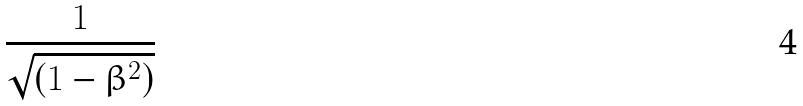<formula> <loc_0><loc_0><loc_500><loc_500>\frac { 1 } { \sqrt { ( 1 - \beta ^ { 2 } ) } }</formula> 